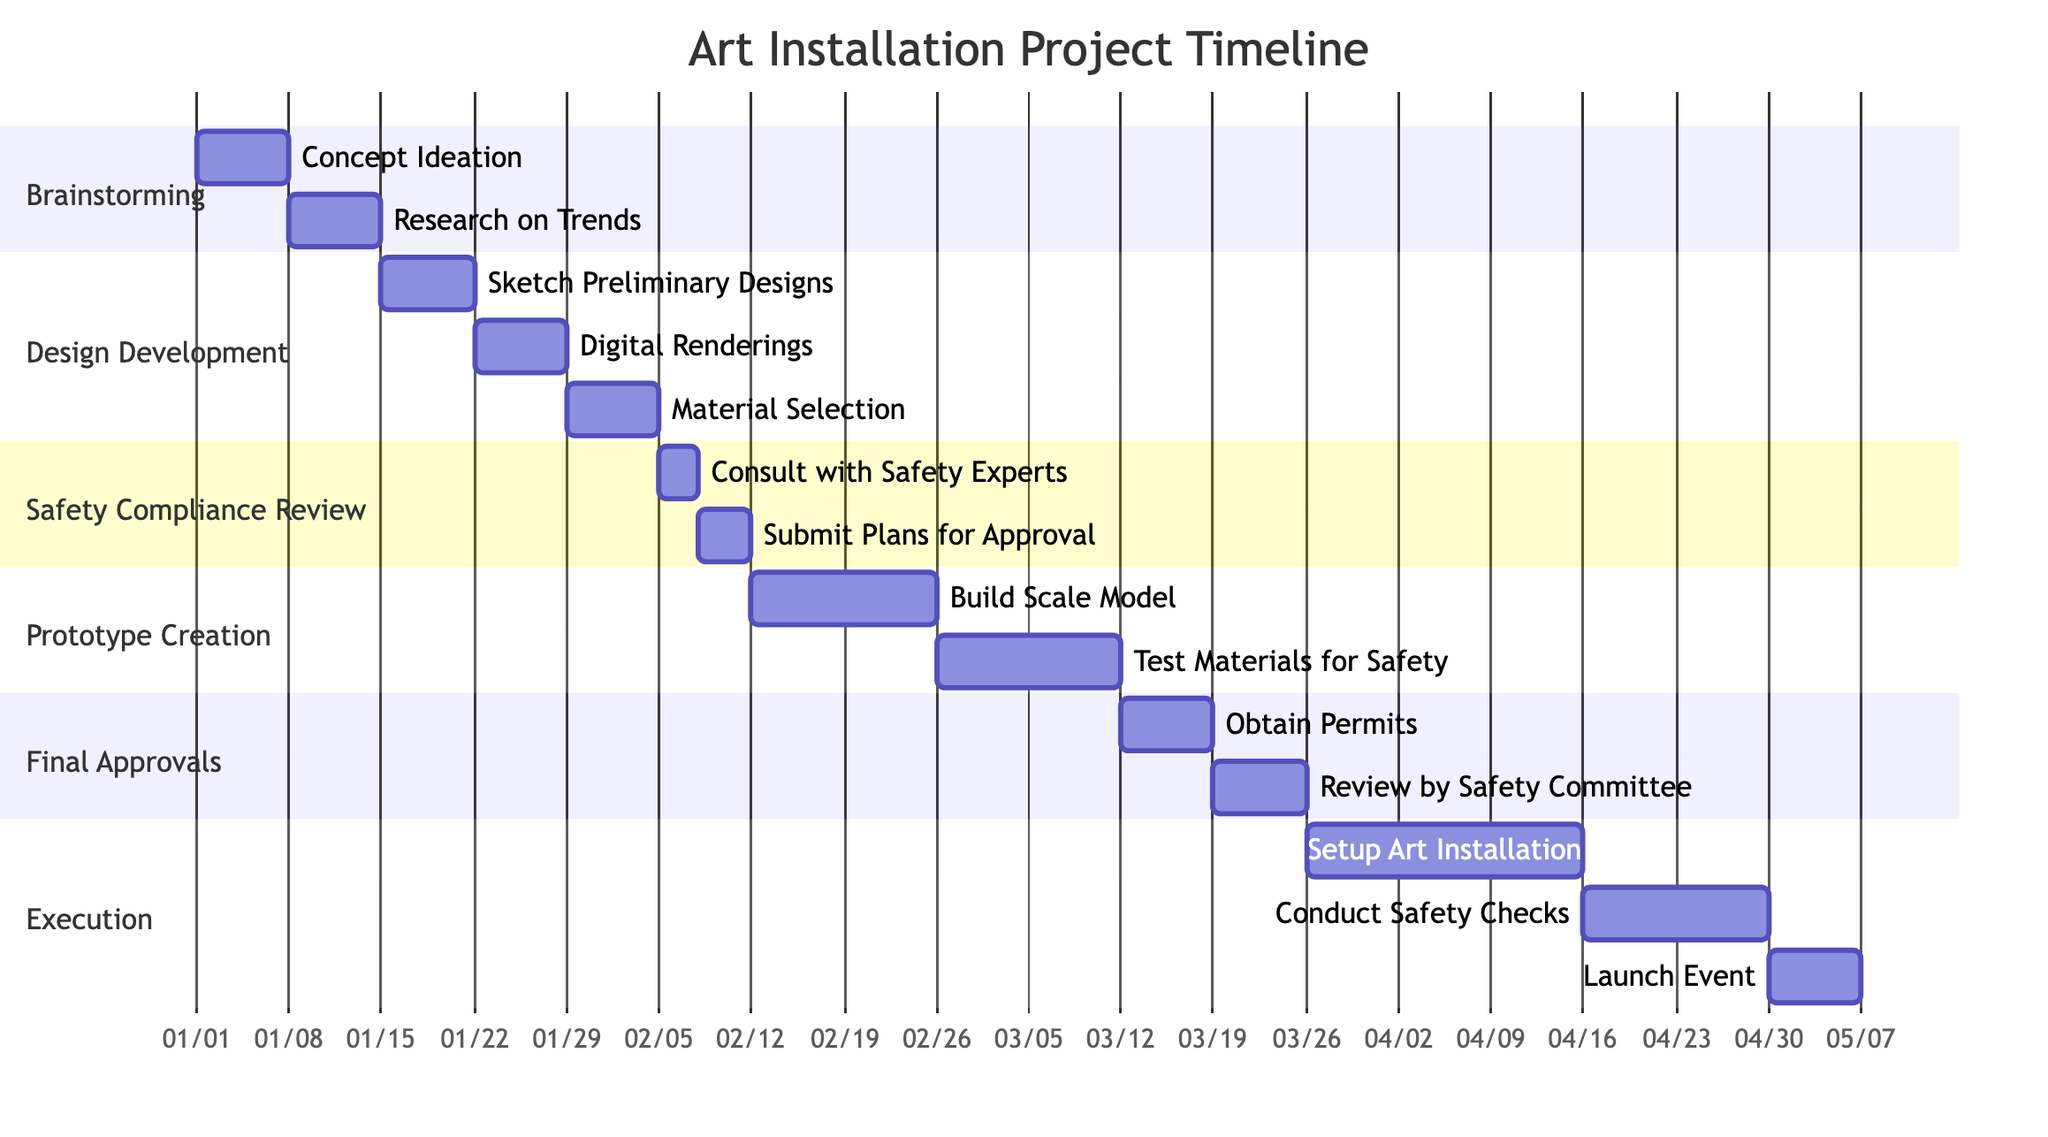What is the duration of the Design Development phase? The diagram shows that the Design Development phase lasts 3 weeks, as explicitly stated in the phase's information section.
Answer: 3 weeks How many milestones are there in the Safety Compliance Review phase? The Safety Compliance Review phase includes two milestones: "Consult with Safety Experts" and "Submit Plans for Approval." Therefore, the total number of milestones in this phase is two.
Answer: 2 What is the first milestone of the Execution phase? The Execution phase begins with the milestone "Setup Art Installation," which is the first listed in that section of the diagram.
Answer: Setup Art Installation What phase occurs after Prototype Creation? According to the sequence of phases in the diagram, the phase that follows Prototype Creation is Final Approvals. This is determined by looking at the arrangement of phases in chronological order.
Answer: Final Approvals How long is the total duration from Brainstorming to Execution? The total duration is calculated by adding the durations of all the phases: 2 weeks (Brainstorming) + 3 weeks (Design Development) + 1 week (Safety Compliance Review) + 4 weeks (Prototype Creation) + 2 weeks (Final Approvals) + 6 weeks (Execution) = 18 weeks total.
Answer: 18 weeks In which phase are "Test Materials for Safety" completed? "Test Materials for Safety" is a milestone that falls under the Prototype Creation phase, as indicated in the diagram's listing of milestones within that phase.
Answer: Prototype Creation What is the duration of the Safety Compliance Review phase compared to the Final Approvals phase? The duration of the Safety Compliance Review phase is 1 week, while the Final Approvals phase lasts 2 weeks. Therefore, the Final Approvals phase is 1 week longer than the Safety Compliance Review phase.
Answer: 1 week longer How many total phases are listed in the diagram? The diagram lists a total of six phases: Brainstorming, Design Development, Safety Compliance Review, Prototype Creation, Final Approvals, and Execution, which are counted to reach this total.
Answer: 6 